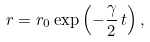Convert formula to latex. <formula><loc_0><loc_0><loc_500><loc_500>r = r _ { 0 } \exp \left ( - \frac { \gamma } { 2 } \, t \right ) ,</formula> 